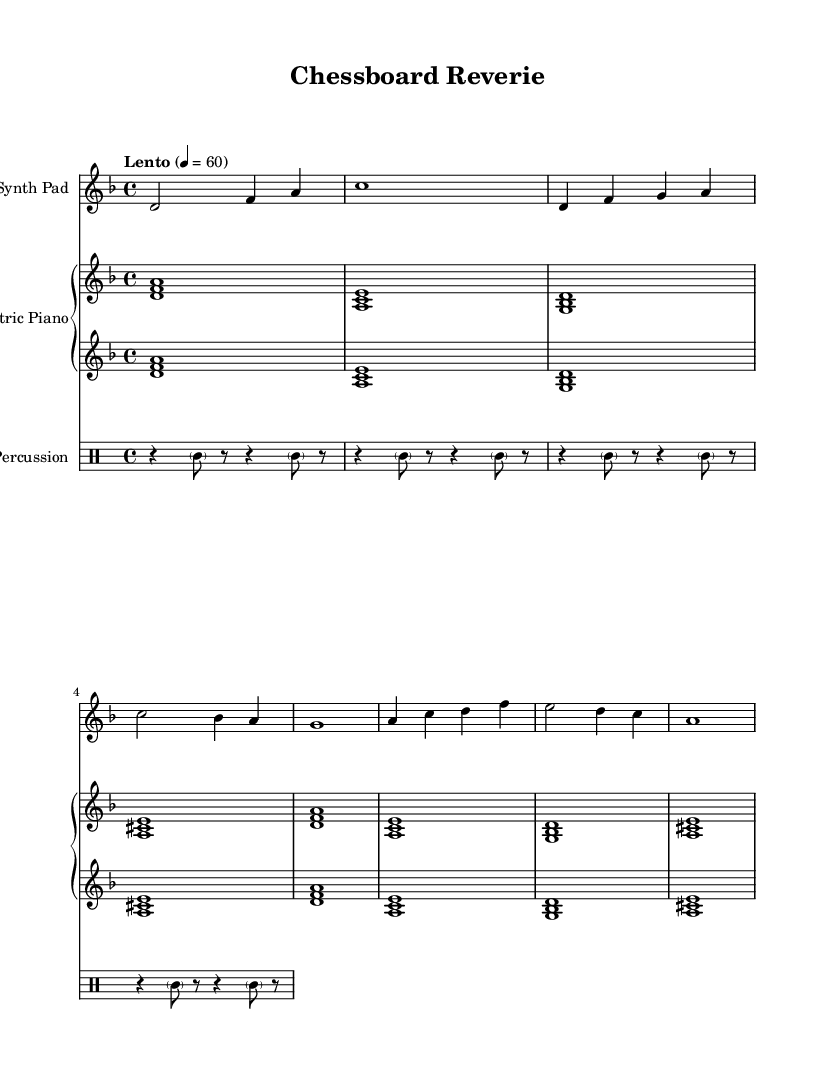What is the key signature of this music? The key signature is indicated by the appearance of the sharp or flat symbols in the music. In this case, there are no sharp or flat symbols present, indicating D minor with one flat (B flat).
Answer: D minor What is the time signature of the piece? The time signature is represented at the beginning of the score, which is 4/4 in this case. This means there are four beats in a measure and the quarter note gets one beat.
Answer: 4/4 What is the tempo marking for the piece? The tempo marking, shown just below the key signature, indicates the speed of the music. Here it reads “Lento” with a metronome marking of 60 beats per minute, indicating a slow tempo.
Answer: Lento How many measures are there in the synth pad part? By counting each vertical line (bar lines) in the synth pad part, we can determine the number of measures present. There are a total of 8 measures in the synth pad part.
Answer: 8 What is the instrumentation for this piece? The score label presents the instruments used, which are "Synth Pad," "Electric Piano," and "Percussion." Each part corresponds to an instrument and contributes to the ambient electronic sound.
Answer: Synth Pad, Electric Piano, Percussion What type of percussion notation is used in this music? The percussion part uses a drum staff for notation, which shows varied rhythms with a combination of rests and notes, and is indicated with a clef specific to percussion instruments.
Answer: Percussion clef What kind of harmony is featured in the electric piano part? The electric piano part consists of block chords played simultaneously, which creates fullness and a rich harmonic texture typical in ambient music, indicated by the engagement of multiple notes together.
Answer: Block chords 